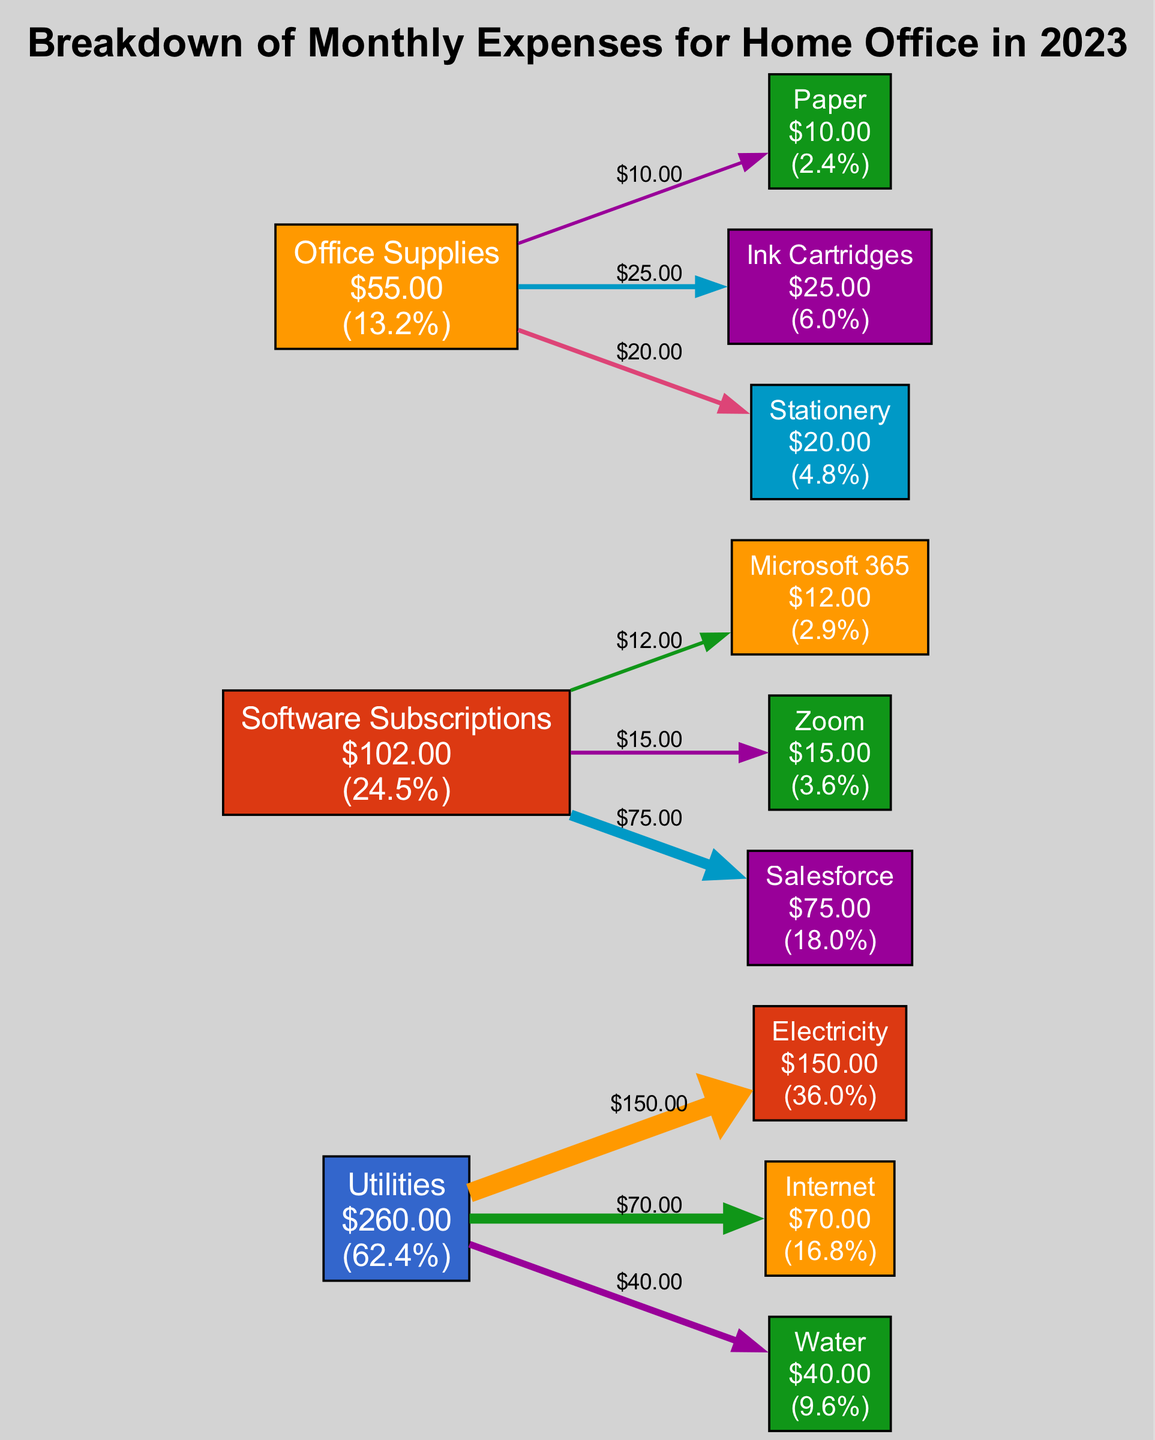What is the total expense for Software Subscriptions? The total expense for Software Subscriptions is the sum of its outflows. Adding the amounts for Microsoft 365 ($12), Zoom ($15), and Salesforce ($75), we get $12 + $15 + $75 = $102.
Answer: $102 Which utility has the highest monthly expense? Looking at the outflows under Utilities, the amounts are Electricity ($150), Internet ($70), and Water ($40). The highest amount among these is Electricity at $150.
Answer: Electricity What is the total monthly expense for the home office? The total expense is the sum of all outflows from all sources. Summing all the outflows: Utilities ($150 + $70 + $40 = $260), Software Subscriptions ($102), and Office Supplies ($10 + $25 + $20 = $55). Thus, total expenses are $260 + $102 + $55 = $417.
Answer: $417 How much is spent on Ink Cartridges? The outflow for Ink Cartridges under Office Supplies is specified as $25. This value is directly provided in the diagram.
Answer: $25 Which category has the least total expense? To determine this, we compare the total expenses of each category: Utilities ($260), Software Subscriptions ($102), and Office Supplies ($55). The smallest is Office Supplies at $55.
Answer: Office Supplies What percentage of the total expenses is attributed to Internet? The expense for Internet is $70. To find the percentage, divide the Internet expense by the total expenses: ($70 / $417) * 100 = 16.8%. This requires understanding of total expenses and precise calculation.
Answer: 16.8% How many outflows are there in total? Each source (Utilities, Software Subscriptions, Office Supplies) has its respective outflows. Counting them gives: 3 (Utilities) + 3 (Software Subscriptions) + 3 (Office Supplies) = 9 outflows total.
Answer: 9 Which software subscription has the highest expense? The outflows for Software Subscriptions are Microsoft 365 ($12), Zoom ($15), and Salesforce ($75). The highest is Salesforce at $75.
Answer: Salesforce 